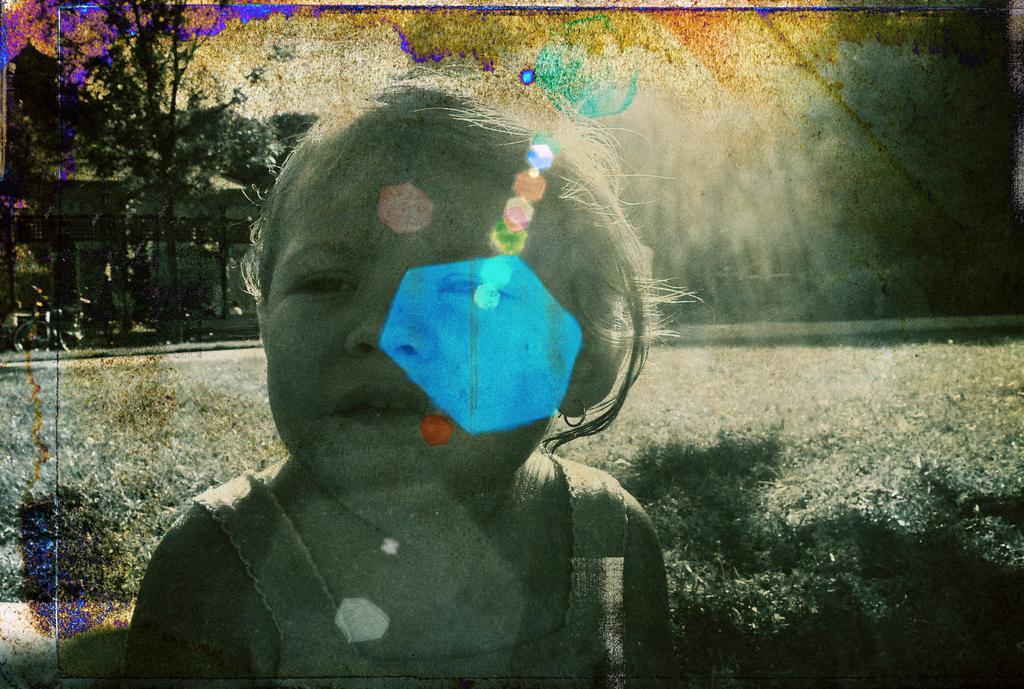Could you give a brief overview of what you see in this image? As we can see in the image there is grass, a child standing in the front and in the background there are trees. 